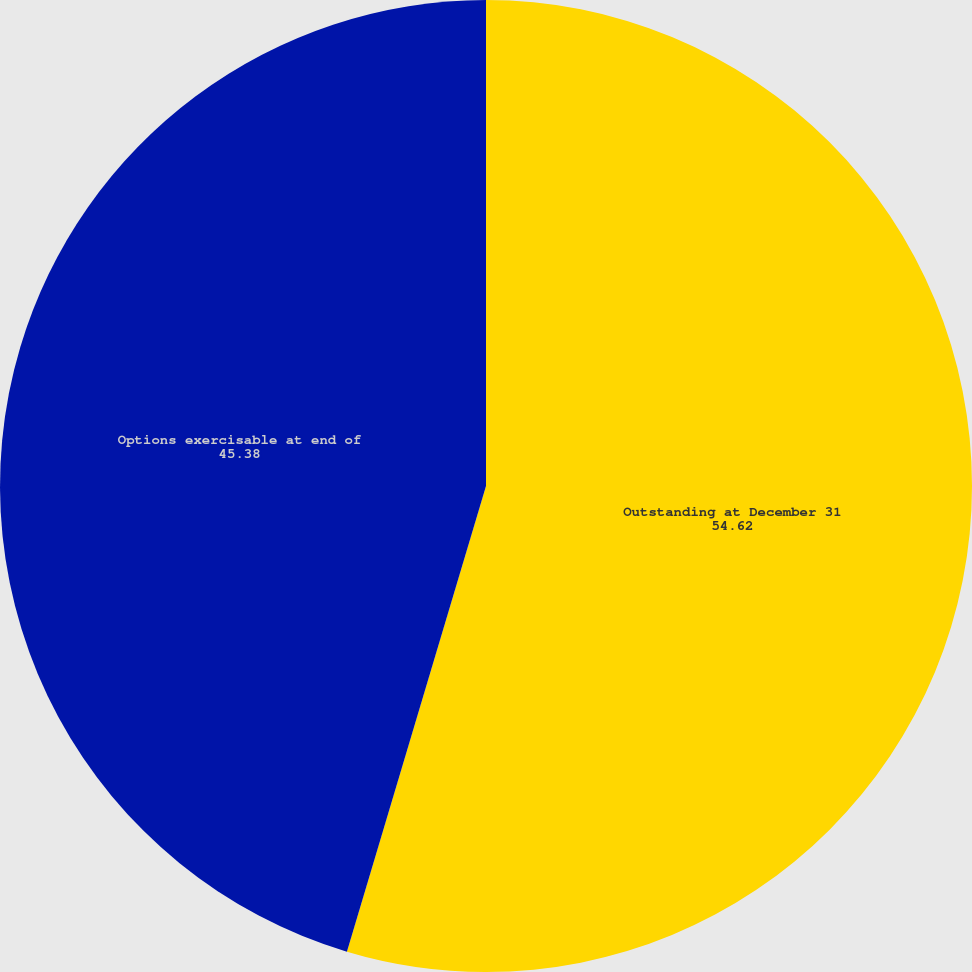<chart> <loc_0><loc_0><loc_500><loc_500><pie_chart><fcel>Outstanding at December 31<fcel>Options exercisable at end of<nl><fcel>54.62%<fcel>45.38%<nl></chart> 